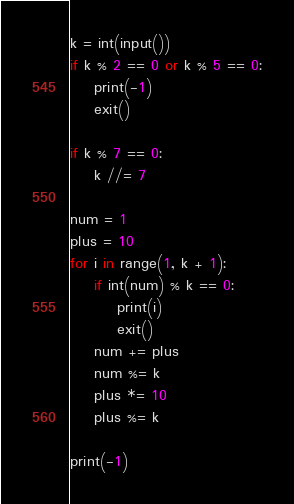Convert code to text. <code><loc_0><loc_0><loc_500><loc_500><_Python_>k = int(input())
if k % 2 == 0 or k % 5 == 0:
    print(-1)
    exit()
    
if k % 7 == 0:
    k //= 7

num = 1
plus = 10
for i in range(1, k + 1):
    if int(num) % k == 0:
        print(i)
        exit()
    num += plus
    num %= k
    plus *= 10
    plus %= k

print(-1)        </code> 